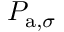Convert formula to latex. <formula><loc_0><loc_0><loc_500><loc_500>P _ { a , \sigma }</formula> 